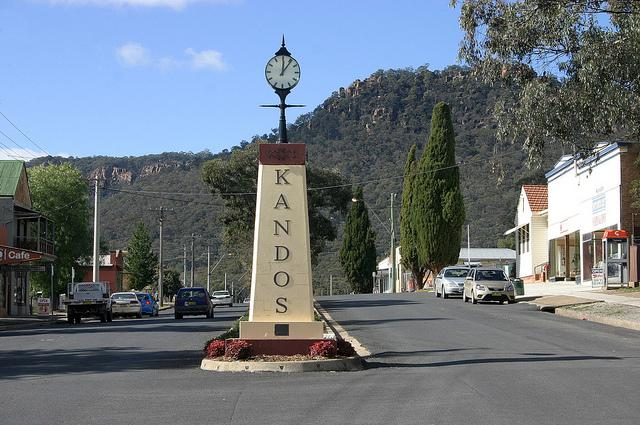What animal is native to this country? Please explain your reasoning. kangaroo. Kandos is in australia which has kangaroos. 